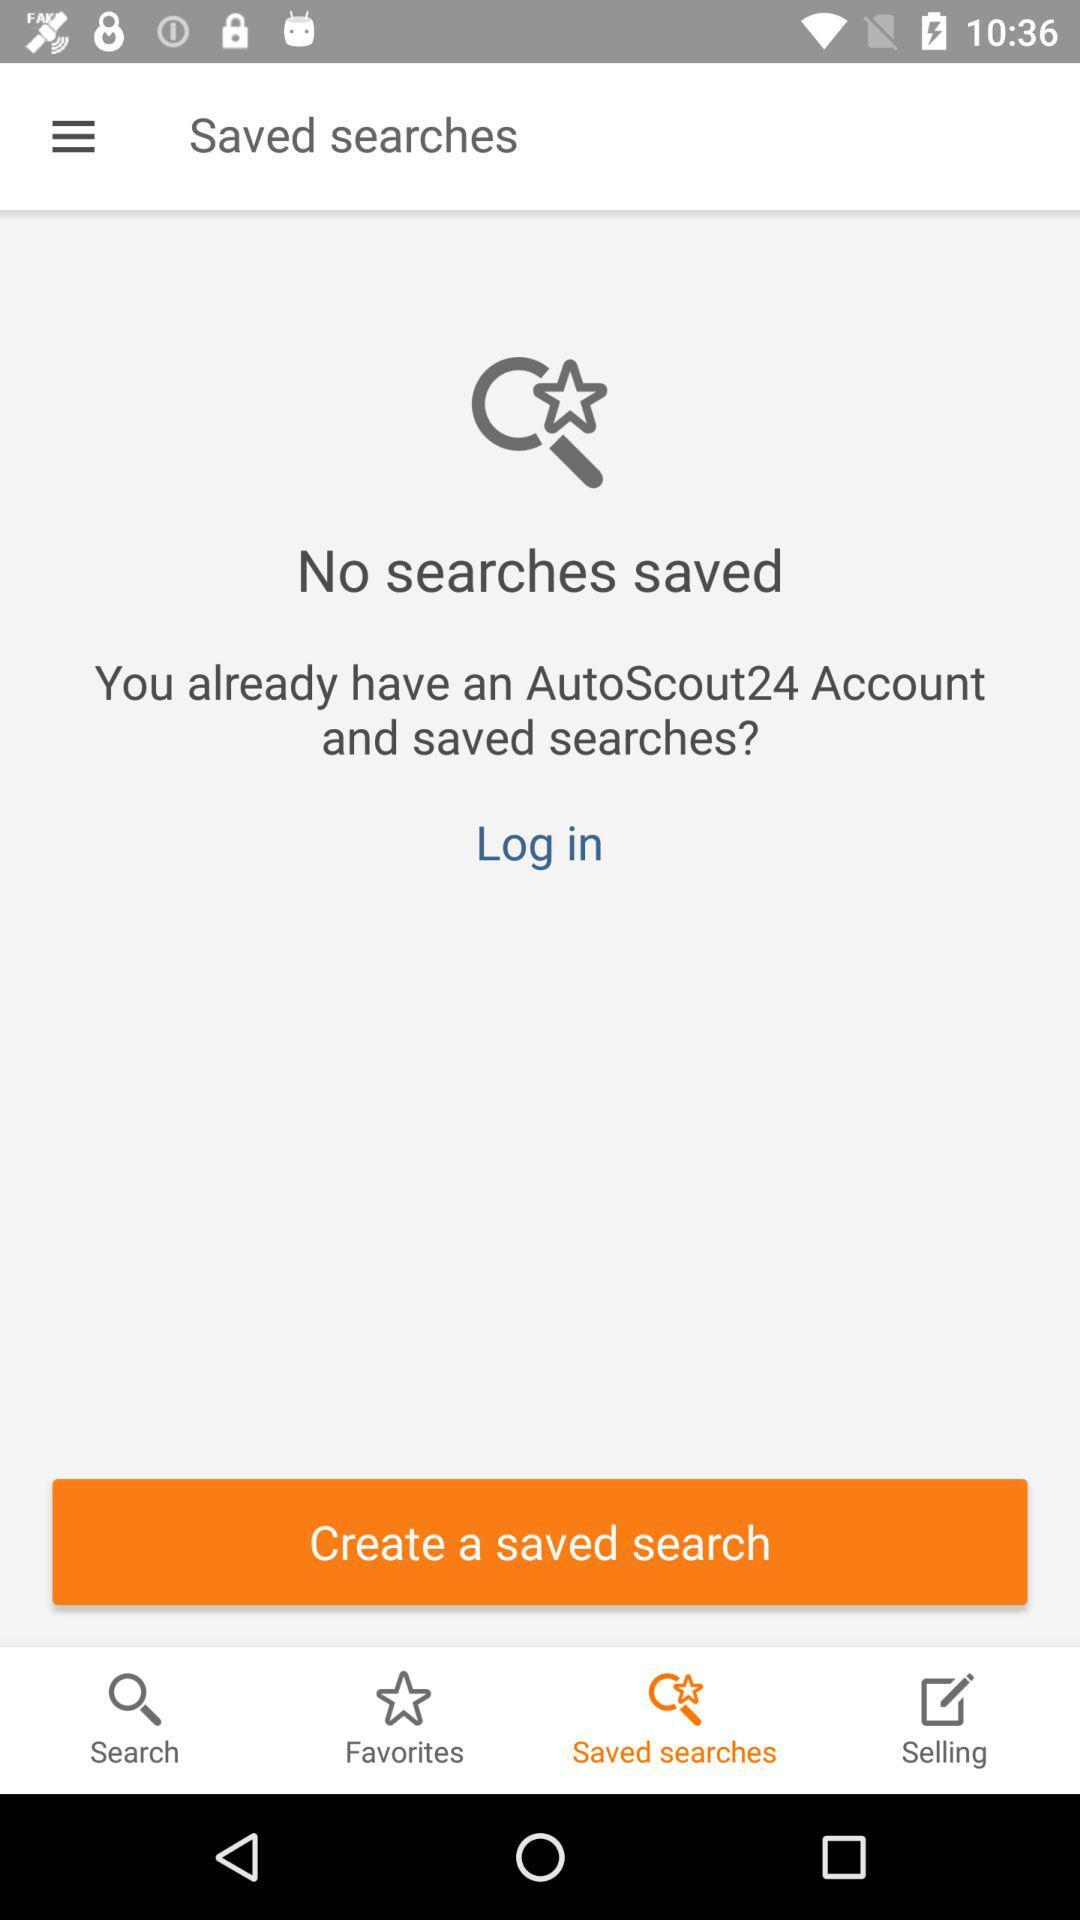How many searches are saved? There are no searches saved. 